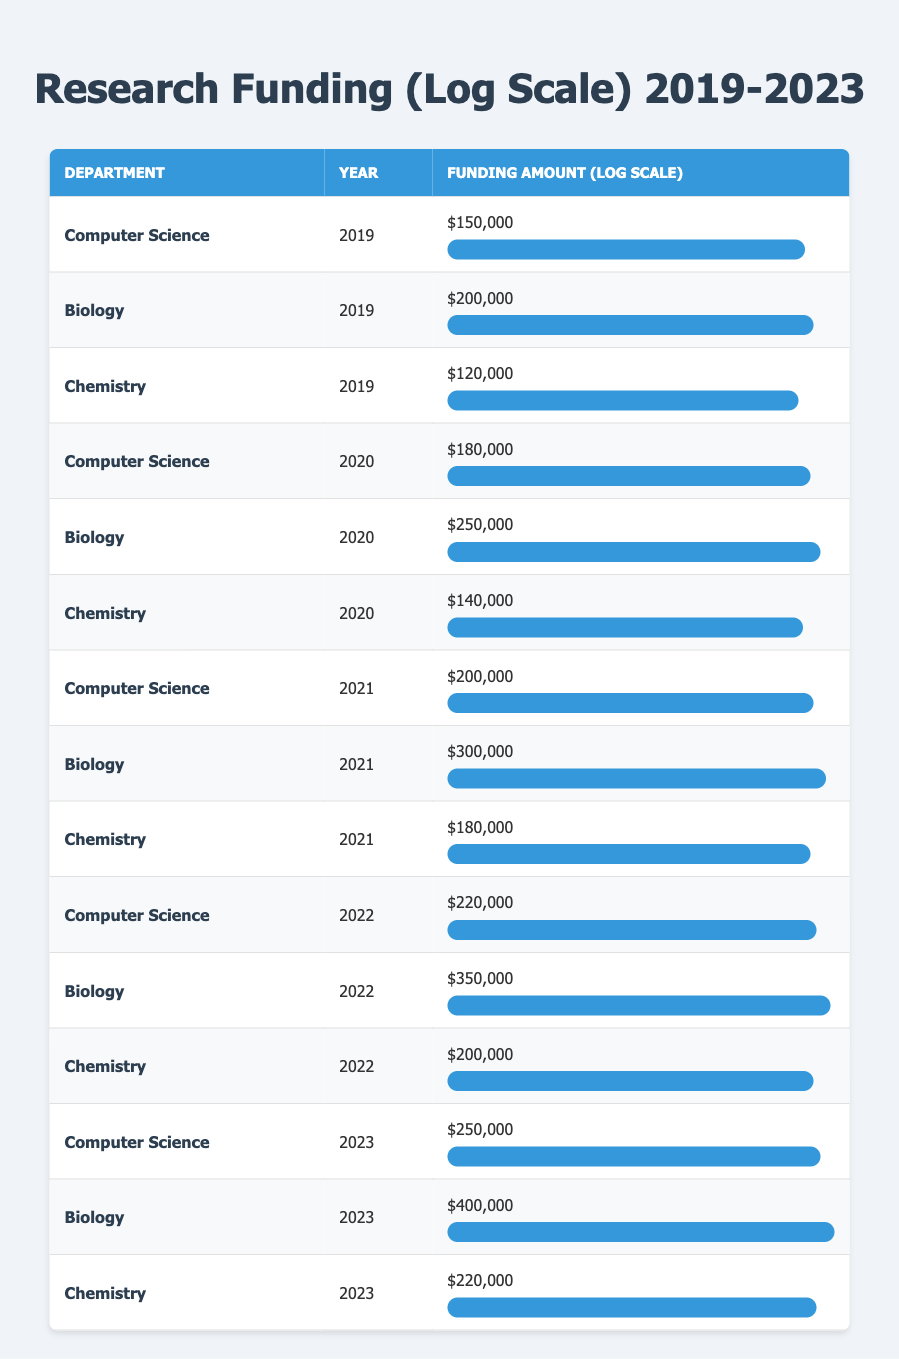What is the highest funding amount received by the Biology department? By examining the rows related to the Biology department, the funding amounts in the years listed are 200000, 250000, 300000, 350000, and 400000. The highest value among these is 400000.
Answer: 400000 In which year did the Computer Science department receive the least funding? Looking at the Computer Science entries for each year (150000, 180000, 200000, 220000, 250000), 150000 in 2019 is the smallest funding amount.
Answer: 2019 What is the average funding amount received by the Chemistry department over the five years? The funding amounts for Chemistry are: 120000, 140000, 180000, 200000, and 220000. Summing these amounts gives 1100000, and dividing by 5 (the number of years) results in an average of 220000.
Answer: 220000 Did the funding for Biology increase every year from 2019 to 2023? The annual funding amounts for Biology are 200000, 250000, 300000, 350000, and 400000, showing a consistent increase each year without any decreases.
Answer: Yes What is the total funding amount received by all departments in 2022? The funding amounts in 2022 are: Computer Science 220000, Biology 350000, and Chemistry 200000. Summing these gives 220000 + 350000 + 200000 = 770000.
Answer: 770000 In which year did the Chemistry department have the highest funding, and what was that amount? The funding amounts for Chemistry are: 120000 in 2019, 140000 in 2020, 180000 in 2021, 200000 in 2022, and 220000 in 2023. The highest of these is 220000 in 2023.
Answer: 2023, 220000 How much more funding did the Biology department receive in 2023 compared to 2019? The funding amounts for Biology are 200000 in 2019 and 400000 in 2023. The difference is 400000 - 200000 = 200000.
Answer: 200000 Which department had the highest total funding over the five years? The total funding amounts are: Computer Science = 150000 + 180000 + 200000 + 220000 + 250000 = 1080000, Biology = 200000 + 250000 + 300000 + 350000 + 400000 = 1500000, Chemistry = 120000 + 140000 + 180000 + 200000 + 220000 = 1100000. The highest total is for Biology at 1500000.
Answer: Biology 